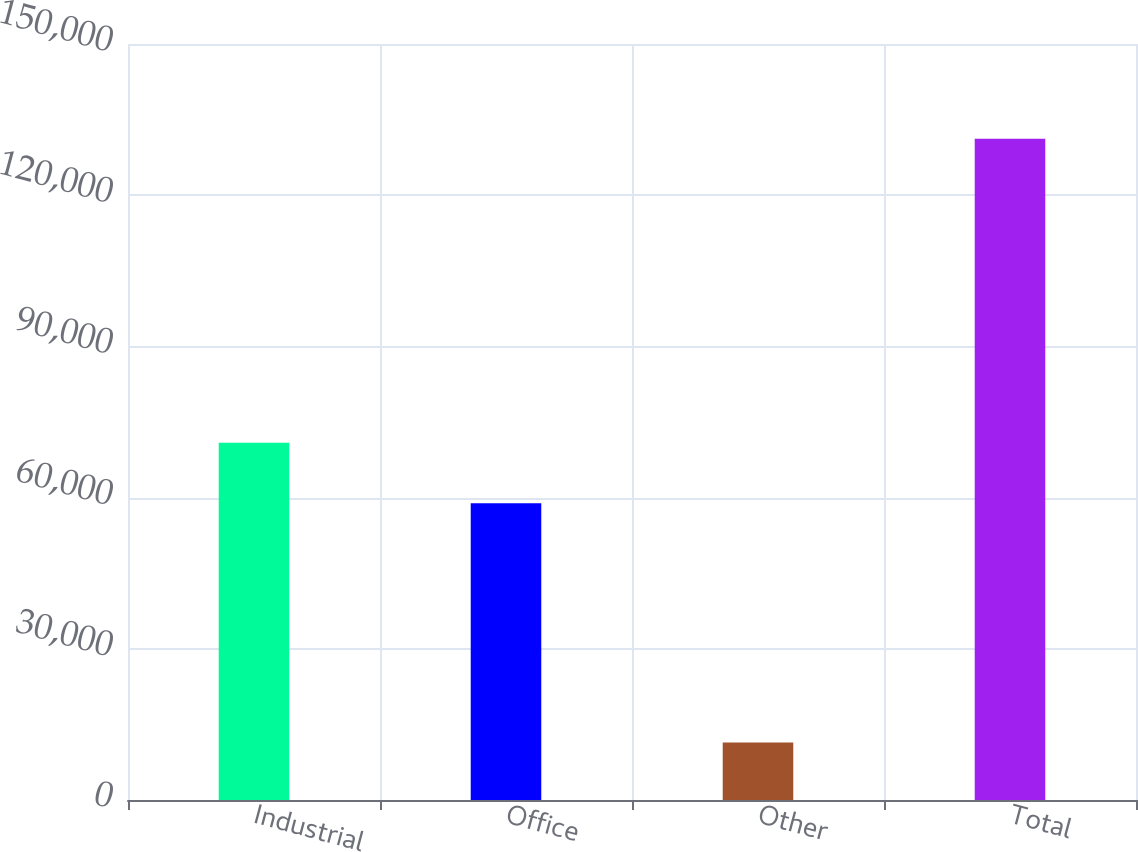Convert chart. <chart><loc_0><loc_0><loc_500><loc_500><bar_chart><fcel>Industrial<fcel>Office<fcel>Other<fcel>Total<nl><fcel>70860.4<fcel>58881<fcel>11400<fcel>131194<nl></chart> 